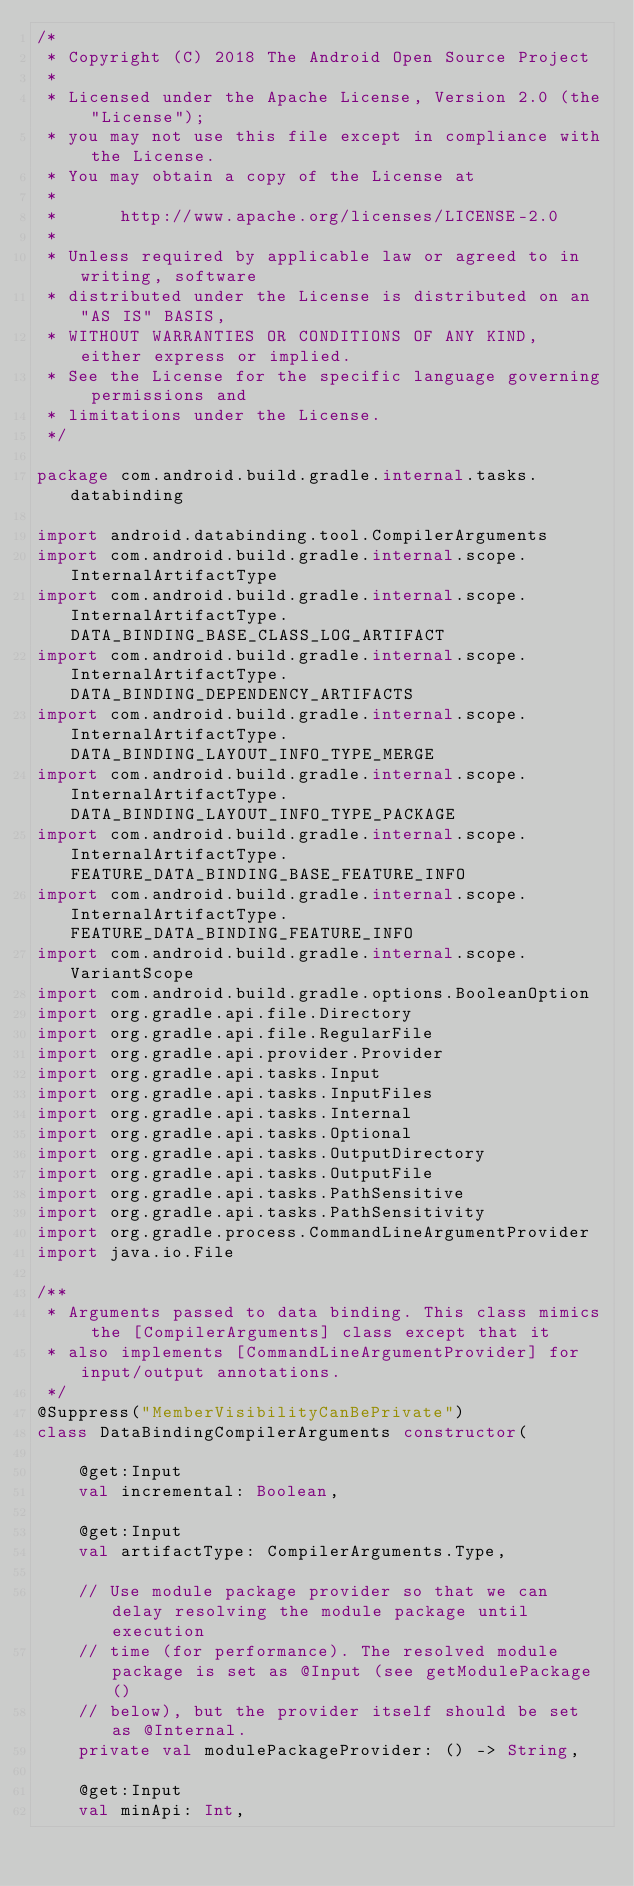Convert code to text. <code><loc_0><loc_0><loc_500><loc_500><_Kotlin_>/*
 * Copyright (C) 2018 The Android Open Source Project
 *
 * Licensed under the Apache License, Version 2.0 (the "License");
 * you may not use this file except in compliance with the License.
 * You may obtain a copy of the License at
 *
 *      http://www.apache.org/licenses/LICENSE-2.0
 *
 * Unless required by applicable law or agreed to in writing, software
 * distributed under the License is distributed on an "AS IS" BASIS,
 * WITHOUT WARRANTIES OR CONDITIONS OF ANY KIND, either express or implied.
 * See the License for the specific language governing permissions and
 * limitations under the License.
 */

package com.android.build.gradle.internal.tasks.databinding

import android.databinding.tool.CompilerArguments
import com.android.build.gradle.internal.scope.InternalArtifactType
import com.android.build.gradle.internal.scope.InternalArtifactType.DATA_BINDING_BASE_CLASS_LOG_ARTIFACT
import com.android.build.gradle.internal.scope.InternalArtifactType.DATA_BINDING_DEPENDENCY_ARTIFACTS
import com.android.build.gradle.internal.scope.InternalArtifactType.DATA_BINDING_LAYOUT_INFO_TYPE_MERGE
import com.android.build.gradle.internal.scope.InternalArtifactType.DATA_BINDING_LAYOUT_INFO_TYPE_PACKAGE
import com.android.build.gradle.internal.scope.InternalArtifactType.FEATURE_DATA_BINDING_BASE_FEATURE_INFO
import com.android.build.gradle.internal.scope.InternalArtifactType.FEATURE_DATA_BINDING_FEATURE_INFO
import com.android.build.gradle.internal.scope.VariantScope
import com.android.build.gradle.options.BooleanOption
import org.gradle.api.file.Directory
import org.gradle.api.file.RegularFile
import org.gradle.api.provider.Provider
import org.gradle.api.tasks.Input
import org.gradle.api.tasks.InputFiles
import org.gradle.api.tasks.Internal
import org.gradle.api.tasks.Optional
import org.gradle.api.tasks.OutputDirectory
import org.gradle.api.tasks.OutputFile
import org.gradle.api.tasks.PathSensitive
import org.gradle.api.tasks.PathSensitivity
import org.gradle.process.CommandLineArgumentProvider
import java.io.File

/**
 * Arguments passed to data binding. This class mimics the [CompilerArguments] class except that it
 * also implements [CommandLineArgumentProvider] for input/output annotations.
 */
@Suppress("MemberVisibilityCanBePrivate")
class DataBindingCompilerArguments constructor(

    @get:Input
    val incremental: Boolean,

    @get:Input
    val artifactType: CompilerArguments.Type,

    // Use module package provider so that we can delay resolving the module package until execution
    // time (for performance). The resolved module package is set as @Input (see getModulePackage()
    // below), but the provider itself should be set as @Internal.
    private val modulePackageProvider: () -> String,

    @get:Input
    val minApi: Int,
</code> 